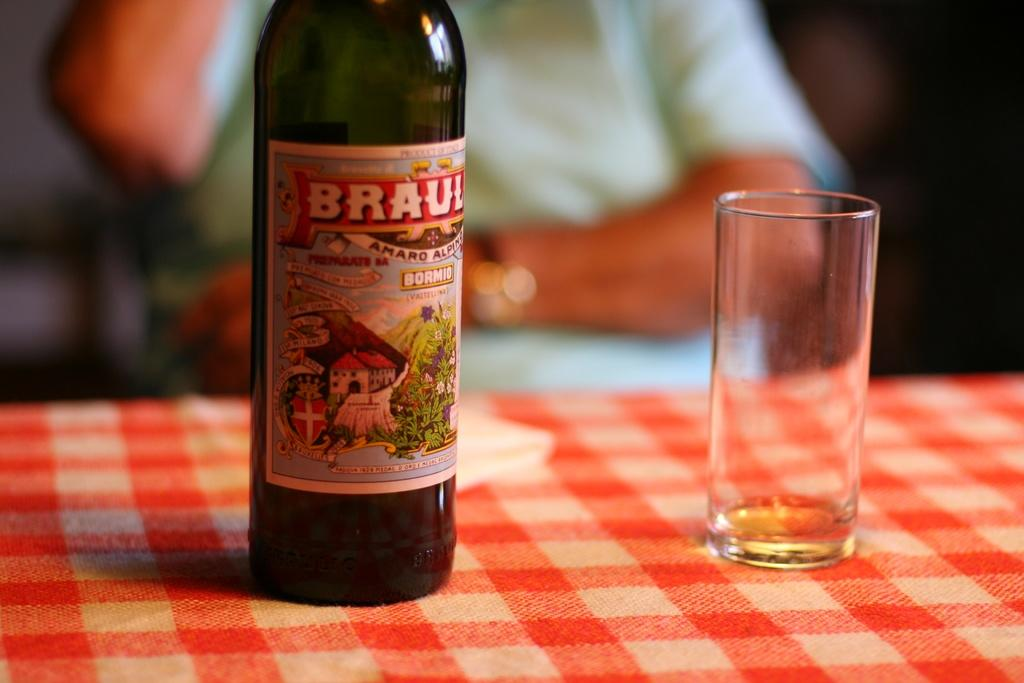What is on the bottle in the image? There is a label on a bottle in the image. What is the glass placed on in the image? The glass is placed on a cloth surface in the image. Can you describe the person in the background of the image? There is a person in the background of the image, but no specific details are provided. What type of pet is sitting on the appliance in the image? There is no pet or appliance present in the image. 